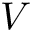<formula> <loc_0><loc_0><loc_500><loc_500>V</formula> 